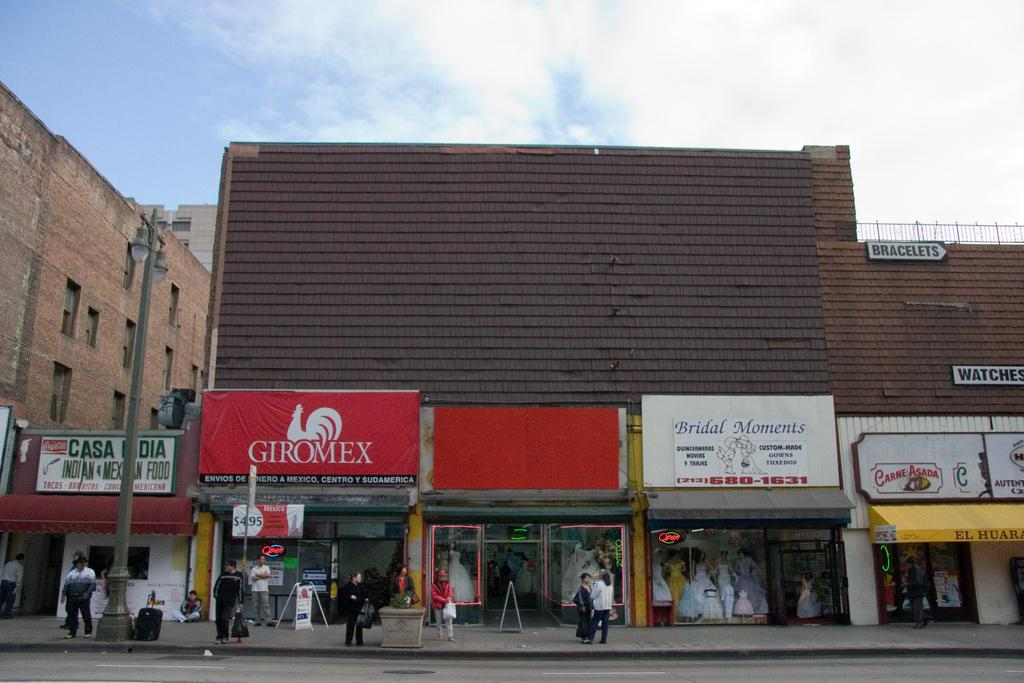<image>
Write a terse but informative summary of the picture. A Giromex store with a red sign is lined up with other stores 